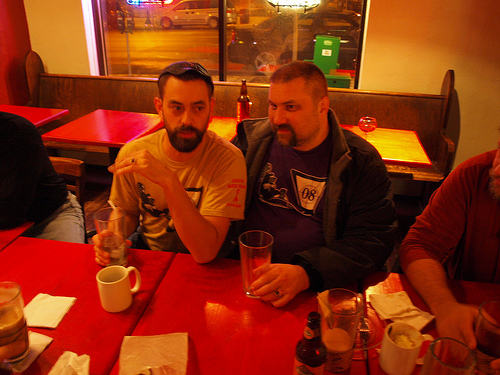<image>
Is there a man on the man? No. The man is not positioned on the man. They may be near each other, but the man is not supported by or resting on top of the man. Is there a beer in front of the head? No. The beer is not in front of the head. The spatial positioning shows a different relationship between these objects. 